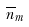Convert formula to latex. <formula><loc_0><loc_0><loc_500><loc_500>\overline { n } _ { m }</formula> 